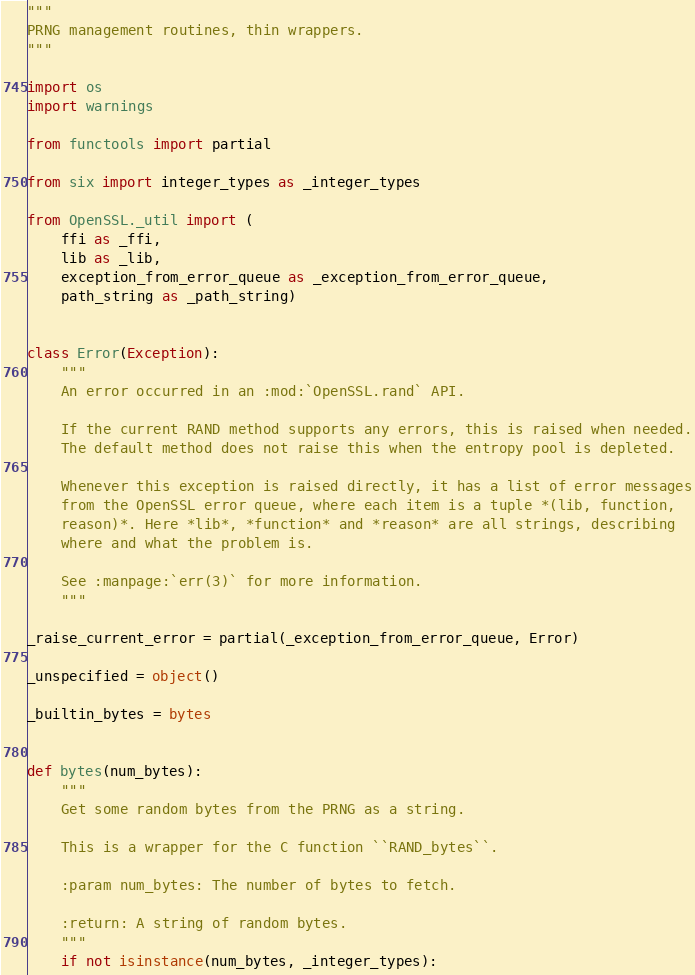<code> <loc_0><loc_0><loc_500><loc_500><_Python_>"""
PRNG management routines, thin wrappers.
"""

import os
import warnings

from functools import partial

from six import integer_types as _integer_types

from OpenSSL._util import (
    ffi as _ffi,
    lib as _lib,
    exception_from_error_queue as _exception_from_error_queue,
    path_string as _path_string)


class Error(Exception):
    """
    An error occurred in an :mod:`OpenSSL.rand` API.

    If the current RAND method supports any errors, this is raised when needed.
    The default method does not raise this when the entropy pool is depleted.

    Whenever this exception is raised directly, it has a list of error messages
    from the OpenSSL error queue, where each item is a tuple *(lib, function,
    reason)*. Here *lib*, *function* and *reason* are all strings, describing
    where and what the problem is.

    See :manpage:`err(3)` for more information.
    """

_raise_current_error = partial(_exception_from_error_queue, Error)

_unspecified = object()

_builtin_bytes = bytes


def bytes(num_bytes):
    """
    Get some random bytes from the PRNG as a string.

    This is a wrapper for the C function ``RAND_bytes``.

    :param num_bytes: The number of bytes to fetch.

    :return: A string of random bytes.
    """
    if not isinstance(num_bytes, _integer_types):</code> 